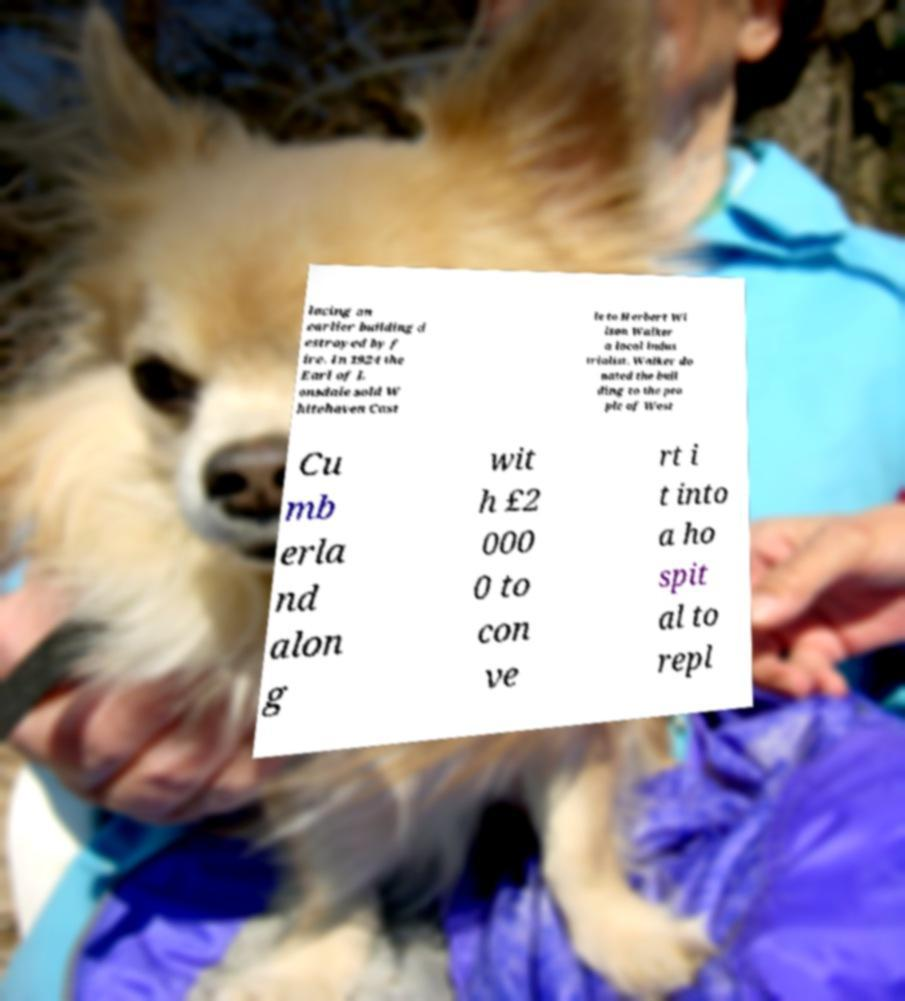I need the written content from this picture converted into text. Can you do that? lacing an earlier building d estroyed by f ire. In 1924 the Earl of L onsdale sold W hitehaven Cast le to Herbert Wi lson Walker a local indus trialist. Walker do nated the buil ding to the peo ple of West Cu mb erla nd alon g wit h £2 000 0 to con ve rt i t into a ho spit al to repl 